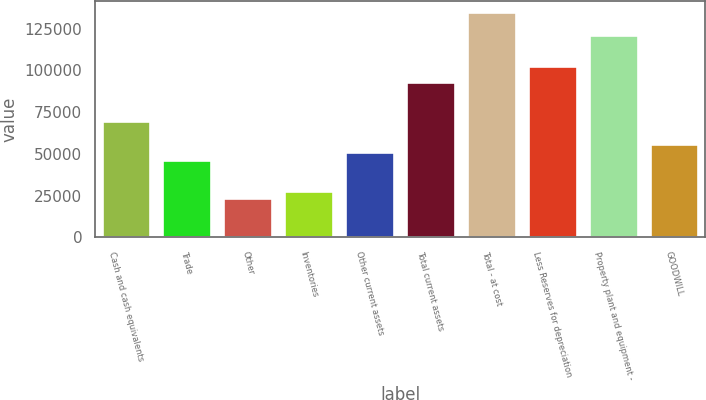Convert chart. <chart><loc_0><loc_0><loc_500><loc_500><bar_chart><fcel>Cash and cash equivalents<fcel>Trade<fcel>Other<fcel>Inventories<fcel>Other current assets<fcel>Total current assets<fcel>Total - at cost<fcel>Less Reserves for depreciation<fcel>Property plant and equipment -<fcel>GOODWILL<nl><fcel>69749<fcel>46522<fcel>23295<fcel>27940.4<fcel>51167.4<fcel>92976<fcel>134785<fcel>102267<fcel>120848<fcel>55812.8<nl></chart> 